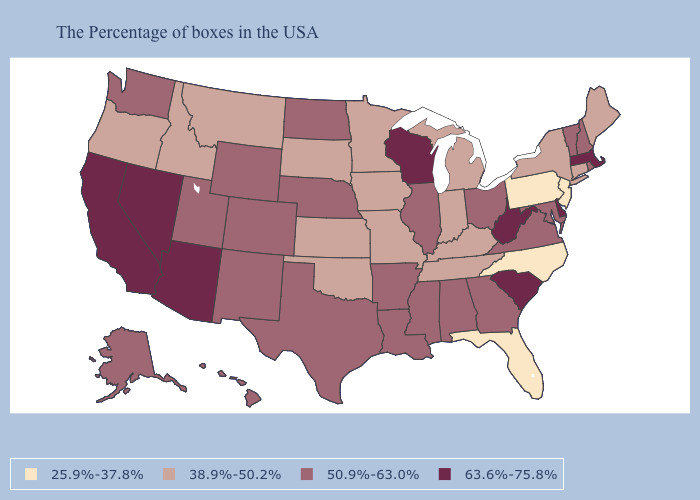Does the first symbol in the legend represent the smallest category?
Answer briefly. Yes. Among the states that border Alabama , does Florida have the lowest value?
Write a very short answer. Yes. What is the value of New Hampshire?
Concise answer only. 50.9%-63.0%. Does New York have the lowest value in the Northeast?
Answer briefly. No. What is the value of Louisiana?
Give a very brief answer. 50.9%-63.0%. Among the states that border Delaware , which have the highest value?
Be succinct. Maryland. What is the lowest value in the USA?
Keep it brief. 25.9%-37.8%. What is the highest value in the South ?
Answer briefly. 63.6%-75.8%. Which states hav the highest value in the MidWest?
Give a very brief answer. Wisconsin. Name the states that have a value in the range 50.9%-63.0%?
Short answer required. Rhode Island, New Hampshire, Vermont, Maryland, Virginia, Ohio, Georgia, Alabama, Illinois, Mississippi, Louisiana, Arkansas, Nebraska, Texas, North Dakota, Wyoming, Colorado, New Mexico, Utah, Washington, Alaska, Hawaii. Name the states that have a value in the range 25.9%-37.8%?
Quick response, please. New Jersey, Pennsylvania, North Carolina, Florida. Does Virginia have a lower value than Massachusetts?
Be succinct. Yes. What is the lowest value in the South?
Concise answer only. 25.9%-37.8%. What is the value of Ohio?
Keep it brief. 50.9%-63.0%. Does New York have the lowest value in the USA?
Keep it brief. No. 